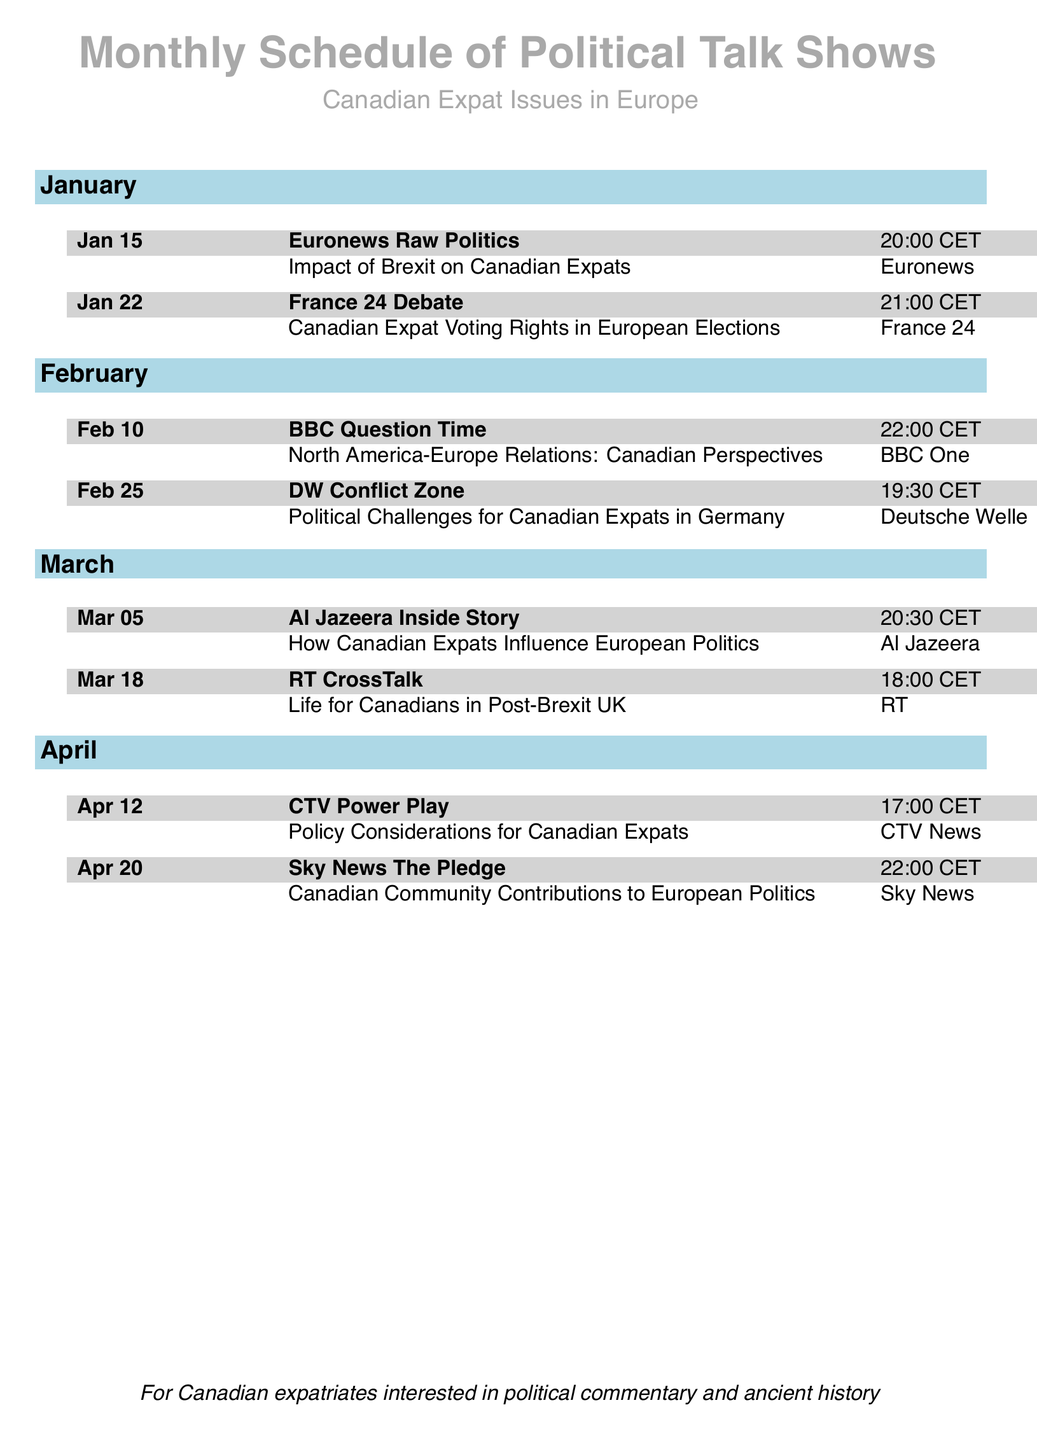what is the title of the talk show on Jan 15? The title of the talk show on Jan 15 is "Euronews Raw Politics."
Answer: Euronews Raw Politics what is the focus of the discussion on Feb 25? The focus of the discussion on Feb 25 is "Political Challenges for Canadian Expats in Germany."
Answer: Political Challenges for Canadian Expats in Germany how many events are scheduled in April? There are two events scheduled in April, one on Apr 12 and another on Apr 20.
Answer: 2 what time does the talk show on Mar 18 start? The talk show on Mar 18 starts at 18:00 CET.
Answer: 18:00 CET which channel broadcasts "BBC Question Time"? The channel that broadcasts "BBC Question Time" is BBC One.
Answer: BBC One what is the primary topic of the discussion on Jan 22? The primary topic of the discussion on Jan 22 is "Canadian Expat Voting Rights in European Elections."
Answer: Canadian Expat Voting Rights in European Elections which month features a show discussing life for Canadians in the Post-Brexit UK? The month featuring a show discussing life for Canadians in the Post-Brexit UK is March.
Answer: March how many talk shows are listed under the month of February? There are two talk shows listed under the month of February.
Answer: 2 